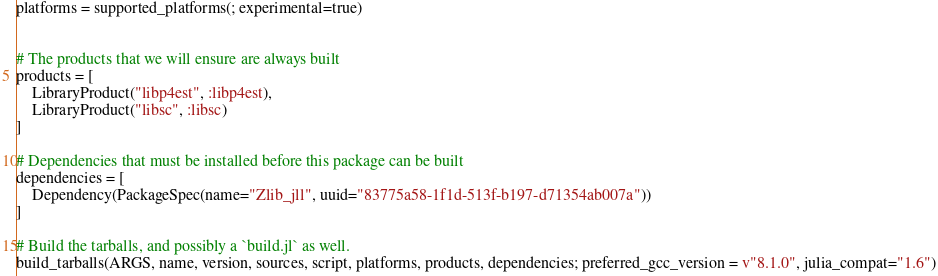<code> <loc_0><loc_0><loc_500><loc_500><_Julia_>platforms = supported_platforms(; experimental=true)


# The products that we will ensure are always built
products = [
    LibraryProduct("libp4est", :libp4est),
    LibraryProduct("libsc", :libsc)
]

# Dependencies that must be installed before this package can be built
dependencies = [
    Dependency(PackageSpec(name="Zlib_jll", uuid="83775a58-1f1d-513f-b197-d71354ab007a"))
]

# Build the tarballs, and possibly a `build.jl` as well.
build_tarballs(ARGS, name, version, sources, script, platforms, products, dependencies; preferred_gcc_version = v"8.1.0", julia_compat="1.6")
</code> 